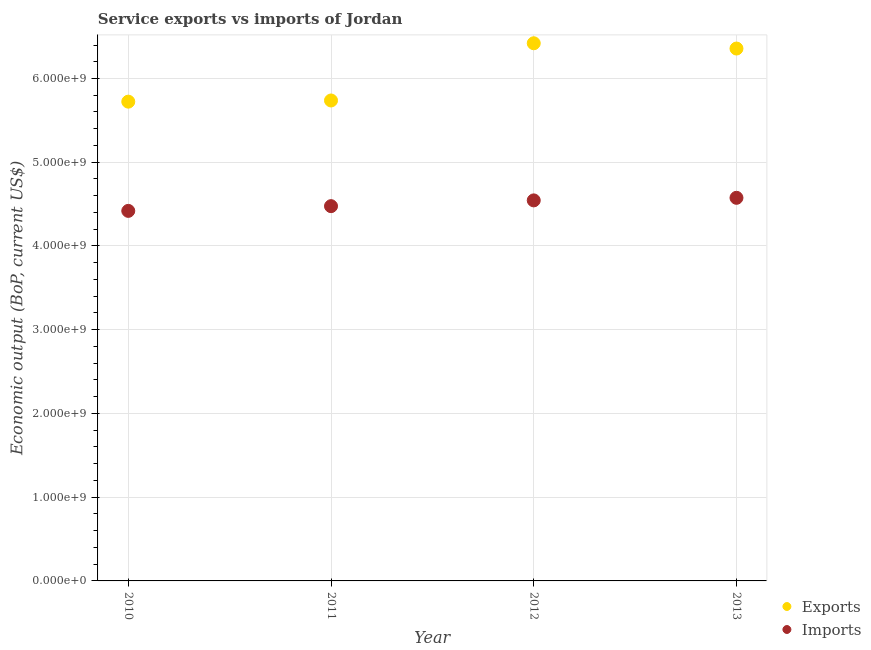Is the number of dotlines equal to the number of legend labels?
Your answer should be compact. Yes. What is the amount of service exports in 2012?
Offer a very short reply. 6.42e+09. Across all years, what is the maximum amount of service imports?
Keep it short and to the point. 4.58e+09. Across all years, what is the minimum amount of service exports?
Ensure brevity in your answer.  5.72e+09. In which year was the amount of service imports maximum?
Keep it short and to the point. 2013. In which year was the amount of service imports minimum?
Your answer should be compact. 2010. What is the total amount of service exports in the graph?
Your answer should be very brief. 2.42e+1. What is the difference between the amount of service exports in 2010 and that in 2012?
Keep it short and to the point. -6.97e+08. What is the difference between the amount of service imports in 2010 and the amount of service exports in 2012?
Offer a terse response. -2.00e+09. What is the average amount of service imports per year?
Keep it short and to the point. 4.50e+09. In the year 2012, what is the difference between the amount of service imports and amount of service exports?
Your answer should be compact. -1.88e+09. What is the ratio of the amount of service imports in 2010 to that in 2012?
Your answer should be compact. 0.97. Is the difference between the amount of service exports in 2010 and 2012 greater than the difference between the amount of service imports in 2010 and 2012?
Ensure brevity in your answer.  No. What is the difference between the highest and the second highest amount of service imports?
Your answer should be compact. 3.07e+07. What is the difference between the highest and the lowest amount of service exports?
Provide a short and direct response. 6.97e+08. In how many years, is the amount of service exports greater than the average amount of service exports taken over all years?
Offer a terse response. 2. Is the sum of the amount of service exports in 2012 and 2013 greater than the maximum amount of service imports across all years?
Make the answer very short. Yes. Is the amount of service exports strictly greater than the amount of service imports over the years?
Provide a succinct answer. Yes. How many years are there in the graph?
Offer a terse response. 4. What is the difference between two consecutive major ticks on the Y-axis?
Offer a terse response. 1.00e+09. Does the graph contain any zero values?
Your response must be concise. No. How many legend labels are there?
Your answer should be very brief. 2. What is the title of the graph?
Your answer should be very brief. Service exports vs imports of Jordan. What is the label or title of the Y-axis?
Make the answer very short. Economic output (BoP, current US$). What is the Economic output (BoP, current US$) of Exports in 2010?
Make the answer very short. 5.72e+09. What is the Economic output (BoP, current US$) in Imports in 2010?
Give a very brief answer. 4.42e+09. What is the Economic output (BoP, current US$) in Exports in 2011?
Your response must be concise. 5.74e+09. What is the Economic output (BoP, current US$) of Imports in 2011?
Provide a succinct answer. 4.48e+09. What is the Economic output (BoP, current US$) in Exports in 2012?
Your response must be concise. 6.42e+09. What is the Economic output (BoP, current US$) of Imports in 2012?
Give a very brief answer. 4.54e+09. What is the Economic output (BoP, current US$) of Exports in 2013?
Offer a terse response. 6.36e+09. What is the Economic output (BoP, current US$) in Imports in 2013?
Your answer should be compact. 4.58e+09. Across all years, what is the maximum Economic output (BoP, current US$) of Exports?
Offer a very short reply. 6.42e+09. Across all years, what is the maximum Economic output (BoP, current US$) of Imports?
Offer a terse response. 4.58e+09. Across all years, what is the minimum Economic output (BoP, current US$) in Exports?
Your answer should be compact. 5.72e+09. Across all years, what is the minimum Economic output (BoP, current US$) in Imports?
Offer a terse response. 4.42e+09. What is the total Economic output (BoP, current US$) of Exports in the graph?
Offer a terse response. 2.42e+1. What is the total Economic output (BoP, current US$) in Imports in the graph?
Keep it short and to the point. 1.80e+1. What is the difference between the Economic output (BoP, current US$) in Exports in 2010 and that in 2011?
Your answer should be compact. -1.39e+07. What is the difference between the Economic output (BoP, current US$) of Imports in 2010 and that in 2011?
Offer a very short reply. -5.65e+07. What is the difference between the Economic output (BoP, current US$) of Exports in 2010 and that in 2012?
Keep it short and to the point. -6.97e+08. What is the difference between the Economic output (BoP, current US$) in Imports in 2010 and that in 2012?
Keep it short and to the point. -1.25e+08. What is the difference between the Economic output (BoP, current US$) of Exports in 2010 and that in 2013?
Your answer should be very brief. -6.34e+08. What is the difference between the Economic output (BoP, current US$) of Imports in 2010 and that in 2013?
Your answer should be compact. -1.56e+08. What is the difference between the Economic output (BoP, current US$) of Exports in 2011 and that in 2012?
Your answer should be very brief. -6.83e+08. What is the difference between the Economic output (BoP, current US$) of Imports in 2011 and that in 2012?
Your response must be concise. -6.89e+07. What is the difference between the Economic output (BoP, current US$) of Exports in 2011 and that in 2013?
Your response must be concise. -6.20e+08. What is the difference between the Economic output (BoP, current US$) of Imports in 2011 and that in 2013?
Offer a terse response. -9.96e+07. What is the difference between the Economic output (BoP, current US$) in Exports in 2012 and that in 2013?
Provide a short and direct response. 6.31e+07. What is the difference between the Economic output (BoP, current US$) in Imports in 2012 and that in 2013?
Provide a succinct answer. -3.07e+07. What is the difference between the Economic output (BoP, current US$) of Exports in 2010 and the Economic output (BoP, current US$) of Imports in 2011?
Ensure brevity in your answer.  1.25e+09. What is the difference between the Economic output (BoP, current US$) in Exports in 2010 and the Economic output (BoP, current US$) in Imports in 2012?
Give a very brief answer. 1.18e+09. What is the difference between the Economic output (BoP, current US$) of Exports in 2010 and the Economic output (BoP, current US$) of Imports in 2013?
Ensure brevity in your answer.  1.15e+09. What is the difference between the Economic output (BoP, current US$) in Exports in 2011 and the Economic output (BoP, current US$) in Imports in 2012?
Your answer should be very brief. 1.19e+09. What is the difference between the Economic output (BoP, current US$) of Exports in 2011 and the Economic output (BoP, current US$) of Imports in 2013?
Offer a terse response. 1.16e+09. What is the difference between the Economic output (BoP, current US$) of Exports in 2012 and the Economic output (BoP, current US$) of Imports in 2013?
Your response must be concise. 1.85e+09. What is the average Economic output (BoP, current US$) in Exports per year?
Your response must be concise. 6.06e+09. What is the average Economic output (BoP, current US$) of Imports per year?
Give a very brief answer. 4.50e+09. In the year 2010, what is the difference between the Economic output (BoP, current US$) in Exports and Economic output (BoP, current US$) in Imports?
Give a very brief answer. 1.30e+09. In the year 2011, what is the difference between the Economic output (BoP, current US$) of Exports and Economic output (BoP, current US$) of Imports?
Make the answer very short. 1.26e+09. In the year 2012, what is the difference between the Economic output (BoP, current US$) of Exports and Economic output (BoP, current US$) of Imports?
Your response must be concise. 1.88e+09. In the year 2013, what is the difference between the Economic output (BoP, current US$) of Exports and Economic output (BoP, current US$) of Imports?
Keep it short and to the point. 1.78e+09. What is the ratio of the Economic output (BoP, current US$) in Exports in 2010 to that in 2011?
Your answer should be very brief. 1. What is the ratio of the Economic output (BoP, current US$) of Imports in 2010 to that in 2011?
Your answer should be compact. 0.99. What is the ratio of the Economic output (BoP, current US$) in Exports in 2010 to that in 2012?
Your answer should be very brief. 0.89. What is the ratio of the Economic output (BoP, current US$) of Imports in 2010 to that in 2012?
Make the answer very short. 0.97. What is the ratio of the Economic output (BoP, current US$) of Exports in 2010 to that in 2013?
Offer a very short reply. 0.9. What is the ratio of the Economic output (BoP, current US$) in Imports in 2010 to that in 2013?
Ensure brevity in your answer.  0.97. What is the ratio of the Economic output (BoP, current US$) of Exports in 2011 to that in 2012?
Your response must be concise. 0.89. What is the ratio of the Economic output (BoP, current US$) of Imports in 2011 to that in 2012?
Provide a succinct answer. 0.98. What is the ratio of the Economic output (BoP, current US$) in Exports in 2011 to that in 2013?
Keep it short and to the point. 0.9. What is the ratio of the Economic output (BoP, current US$) of Imports in 2011 to that in 2013?
Ensure brevity in your answer.  0.98. What is the ratio of the Economic output (BoP, current US$) of Exports in 2012 to that in 2013?
Keep it short and to the point. 1.01. What is the difference between the highest and the second highest Economic output (BoP, current US$) in Exports?
Your answer should be very brief. 6.31e+07. What is the difference between the highest and the second highest Economic output (BoP, current US$) of Imports?
Give a very brief answer. 3.07e+07. What is the difference between the highest and the lowest Economic output (BoP, current US$) in Exports?
Offer a terse response. 6.97e+08. What is the difference between the highest and the lowest Economic output (BoP, current US$) of Imports?
Your answer should be very brief. 1.56e+08. 